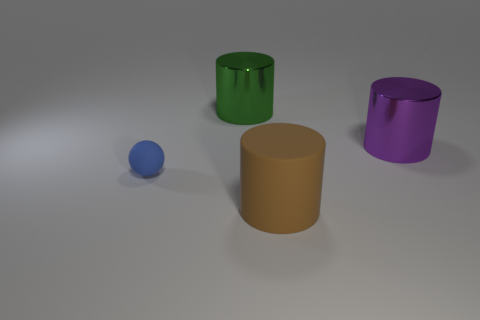Add 1 large cylinders. How many objects exist? 5 Subtract all cylinders. How many objects are left? 1 Add 4 small brown rubber balls. How many small brown rubber balls exist? 4 Subtract 0 purple spheres. How many objects are left? 4 Subtract all big metal cylinders. Subtract all brown objects. How many objects are left? 1 Add 4 metallic objects. How many metallic objects are left? 6 